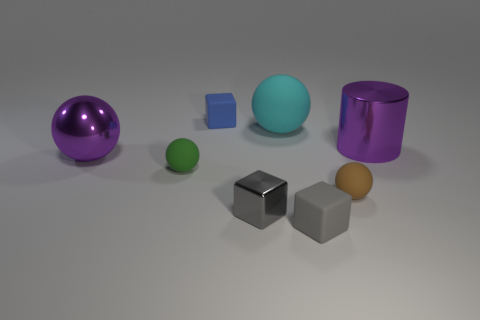Add 1 purple metal things. How many objects exist? 9 Subtract all green spheres. How many spheres are left? 3 Subtract all green spheres. How many spheres are left? 3 Subtract all yellow cylinders. How many yellow balls are left? 0 Add 7 purple cylinders. How many purple cylinders are left? 8 Add 1 matte objects. How many matte objects exist? 6 Subtract 0 cyan cylinders. How many objects are left? 8 Subtract all cylinders. How many objects are left? 7 Subtract 2 cubes. How many cubes are left? 1 Subtract all blue cylinders. Subtract all blue balls. How many cylinders are left? 1 